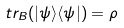Convert formula to latex. <formula><loc_0><loc_0><loc_500><loc_500>t r _ { B } ( | \psi \rangle \langle \psi | ) = \rho</formula> 